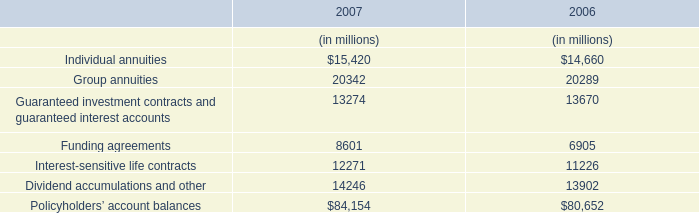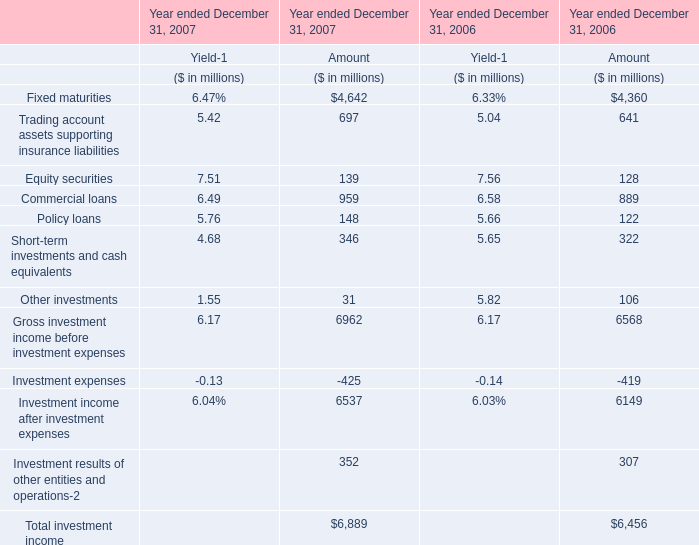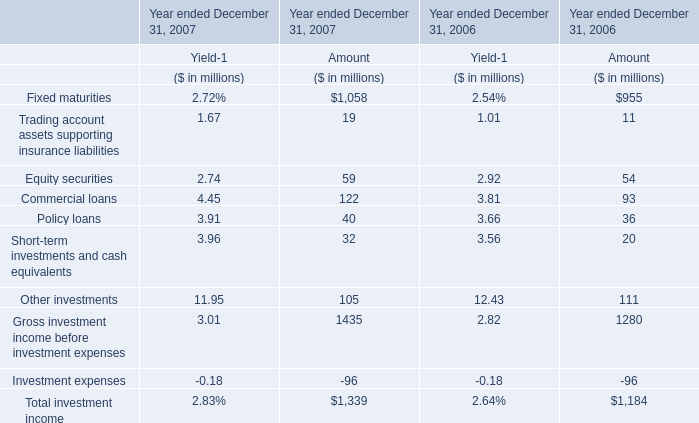What's the total amount of the Fixed maturities in the years where Fixed maturities is greater than 1? 
Computations: (1058 + 955)
Answer: 2013.0. 